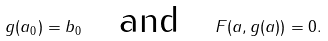<formula> <loc_0><loc_0><loc_500><loc_500>g ( a _ { 0 } ) = b _ { 0 } \quad \text {and} \quad F ( a , g ( a ) ) = 0 .</formula> 